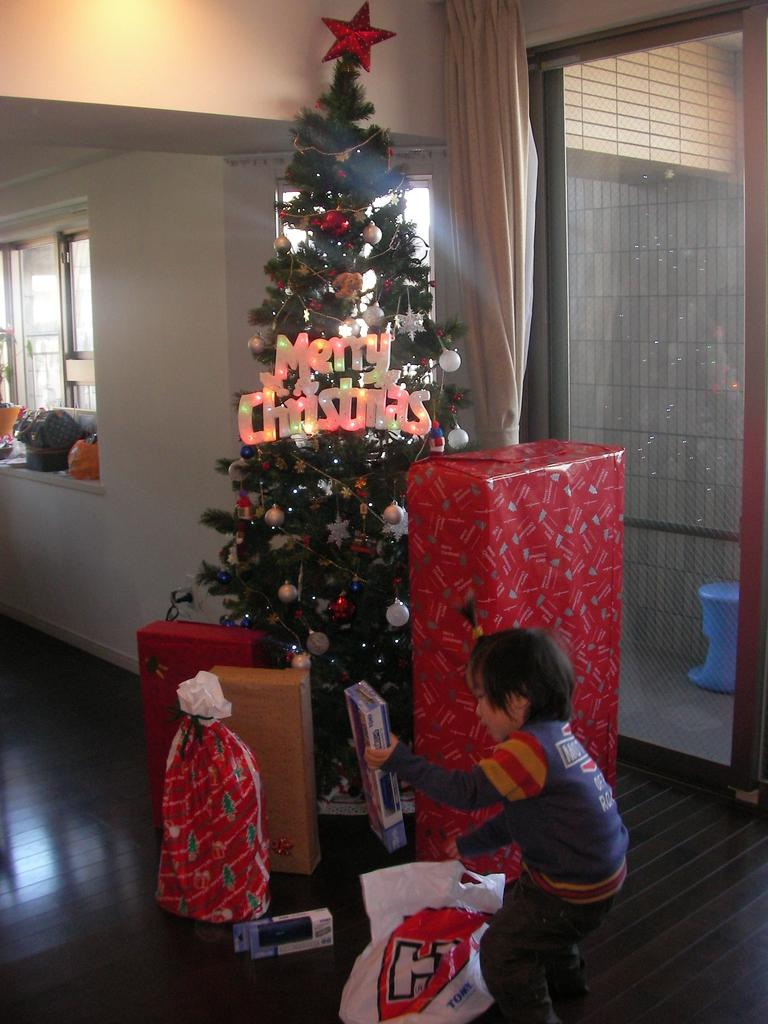<image>
Give a short and clear explanation of the subsequent image. Boy opening gifts by a tree which says Merry Christmas. 